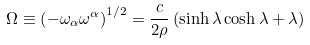<formula> <loc_0><loc_0><loc_500><loc_500>\Omega \equiv \left ( - \omega _ { \alpha } \omega ^ { \alpha } \right ) ^ { 1 / 2 } = \frac { c } { 2 \rho } \left ( \sinh { \lambda } \cosh { \lambda } + \lambda \right )</formula> 